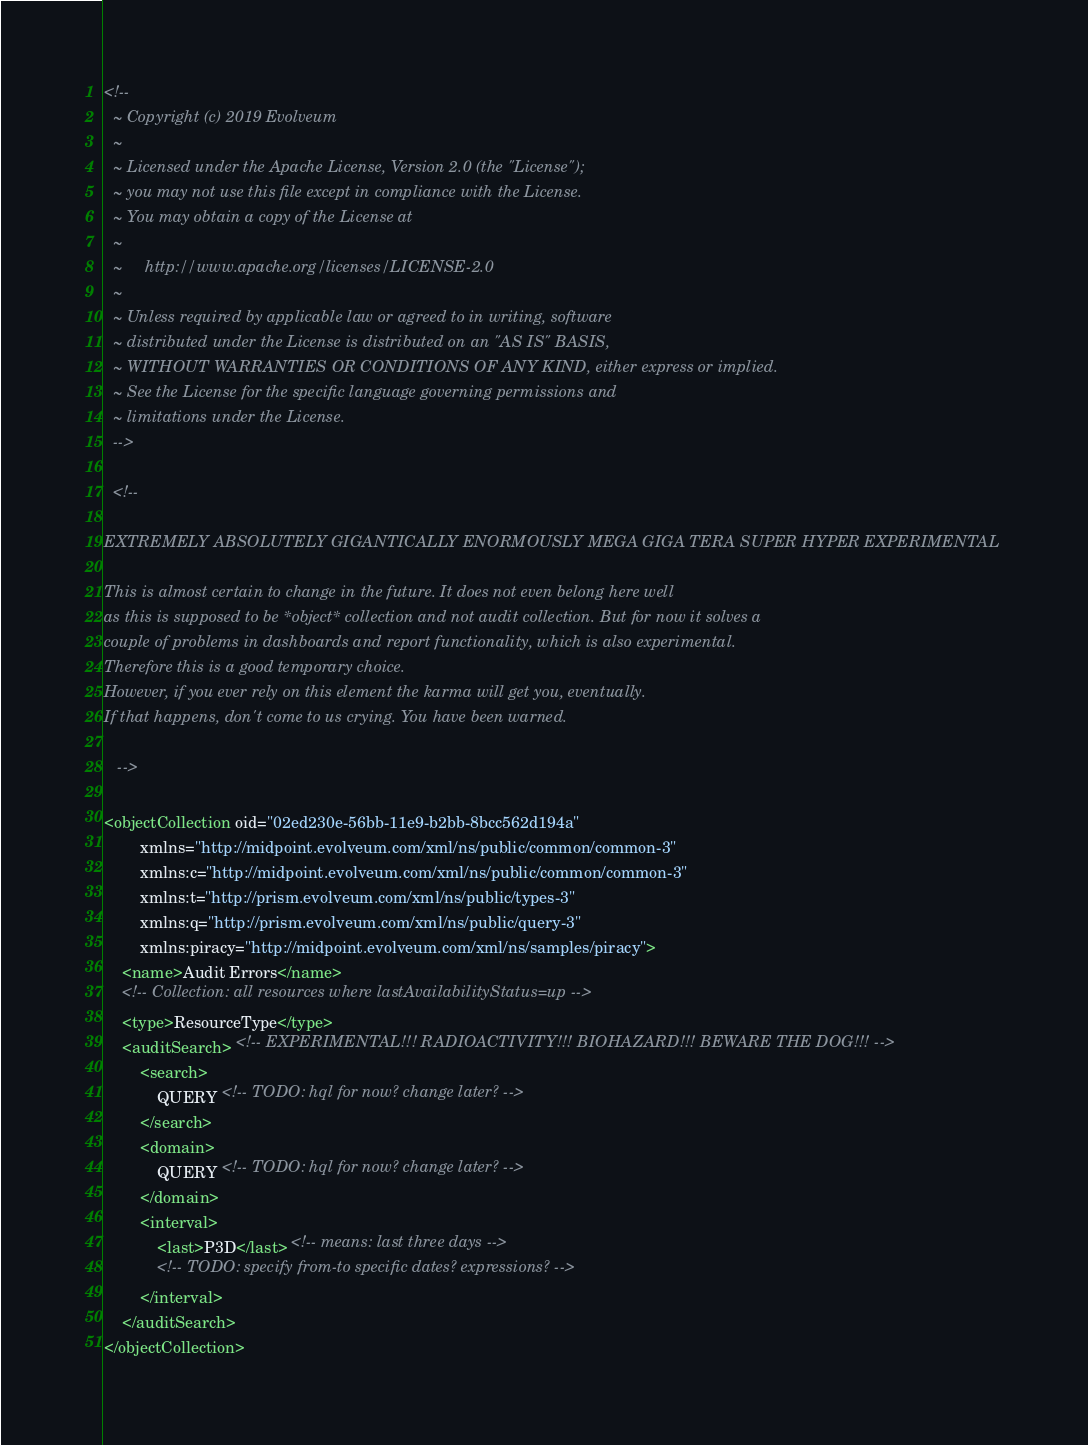Convert code to text. <code><loc_0><loc_0><loc_500><loc_500><_XML_><!--
  ~ Copyright (c) 2019 Evolveum
  ~
  ~ Licensed under the Apache License, Version 2.0 (the "License");
  ~ you may not use this file except in compliance with the License.
  ~ You may obtain a copy of the License at
  ~
  ~     http://www.apache.org/licenses/LICENSE-2.0
  ~
  ~ Unless required by applicable law or agreed to in writing, software
  ~ distributed under the License is distributed on an "AS IS" BASIS,
  ~ WITHOUT WARRANTIES OR CONDITIONS OF ANY KIND, either express or implied.
  ~ See the License for the specific language governing permissions and
  ~ limitations under the License.
  -->

  <!--

EXTREMELY ABSOLUTELY GIGANTICALLY ENORMOUSLY MEGA GIGA TERA SUPER HYPER EXPERIMENTAL

This is almost certain to change in the future. It does not even belong here well
as this is supposed to be *object* collection and not audit collection. But for now it solves a
couple of problems in dashboards and report functionality, which is also experimental.
Therefore this is a good temporary choice.
However, if you ever rely on this element the karma will get you, eventually.
If that happens, don't come to us crying. You have been warned.

   -->

<objectCollection oid="02ed230e-56bb-11e9-b2bb-8bcc562d194a"
        xmlns="http://midpoint.evolveum.com/xml/ns/public/common/common-3"
        xmlns:c="http://midpoint.evolveum.com/xml/ns/public/common/common-3"
        xmlns:t="http://prism.evolveum.com/xml/ns/public/types-3"
        xmlns:q="http://prism.evolveum.com/xml/ns/public/query-3"
        xmlns:piracy="http://midpoint.evolveum.com/xml/ns/samples/piracy">
    <name>Audit Errors</name>
    <!-- Collection: all resources where lastAvailabilityStatus=up -->
    <type>ResourceType</type>
    <auditSearch> <!-- EXPERIMENTAL!!! RADIOACTIVITY!!! BIOHAZARD!!! BEWARE THE DOG!!! -->
        <search>
            QUERY <!-- TODO: hql for now? change later? -->
        </search>
        <domain>
            QUERY <!-- TODO: hql for now? change later? -->
        </domain>
        <interval>
            <last>P3D</last> <!-- means: last three days -->
            <!-- TODO: specify from-to specific dates? expressions? -->
        </interval>
    </auditSearch>
</objectCollection>
</code> 